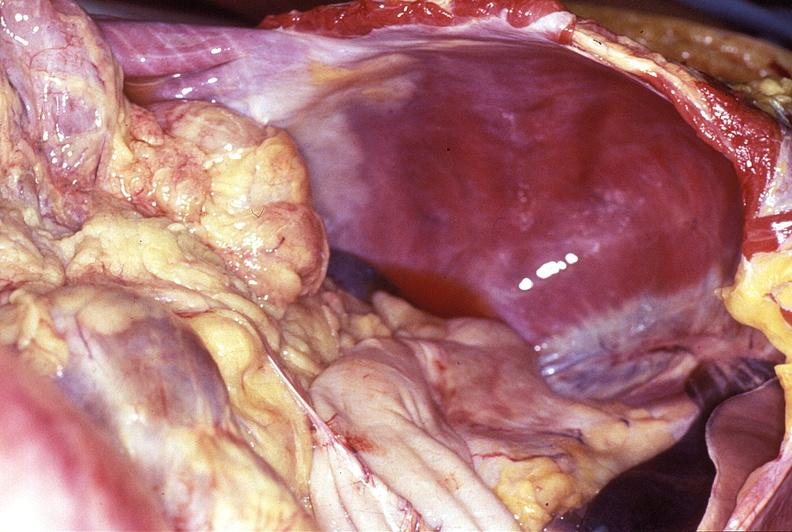where does this belong to?
Answer the question using a single word or phrase. Gastrointestinal system 